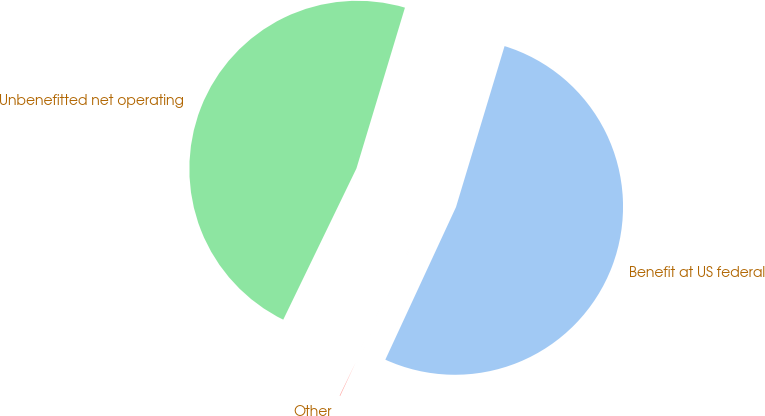Convert chart to OTSL. <chart><loc_0><loc_0><loc_500><loc_500><pie_chart><fcel>Benefit at US federal<fcel>Unbenefitted net operating<fcel>Other<nl><fcel>52.24%<fcel>47.49%<fcel>0.27%<nl></chart> 